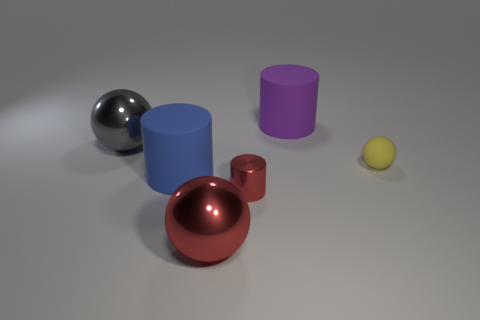Is there a matte object of the same color as the tiny metal cylinder?
Ensure brevity in your answer.  No. How many objects are rubber objects left of the large purple cylinder or big rubber spheres?
Ensure brevity in your answer.  1. Do the yellow thing and the large sphere to the left of the red ball have the same material?
Ensure brevity in your answer.  No. There is another metal thing that is the same color as the small metal thing; what size is it?
Provide a short and direct response. Large. Are there any gray cubes that have the same material as the big blue cylinder?
Provide a succinct answer. No. What number of things are either rubber cylinders in front of the gray shiny ball or matte objects to the right of the small metallic thing?
Give a very brief answer. 3. There is a small yellow matte object; is its shape the same as the small object in front of the large blue cylinder?
Give a very brief answer. No. What number of objects are green cubes or large purple rubber cylinders?
Give a very brief answer. 1. There is a big shiny object in front of the gray object to the left of the tiny yellow object; what is its shape?
Keep it short and to the point. Sphere. Are there fewer yellow matte balls than big shiny spheres?
Your answer should be compact. Yes. 